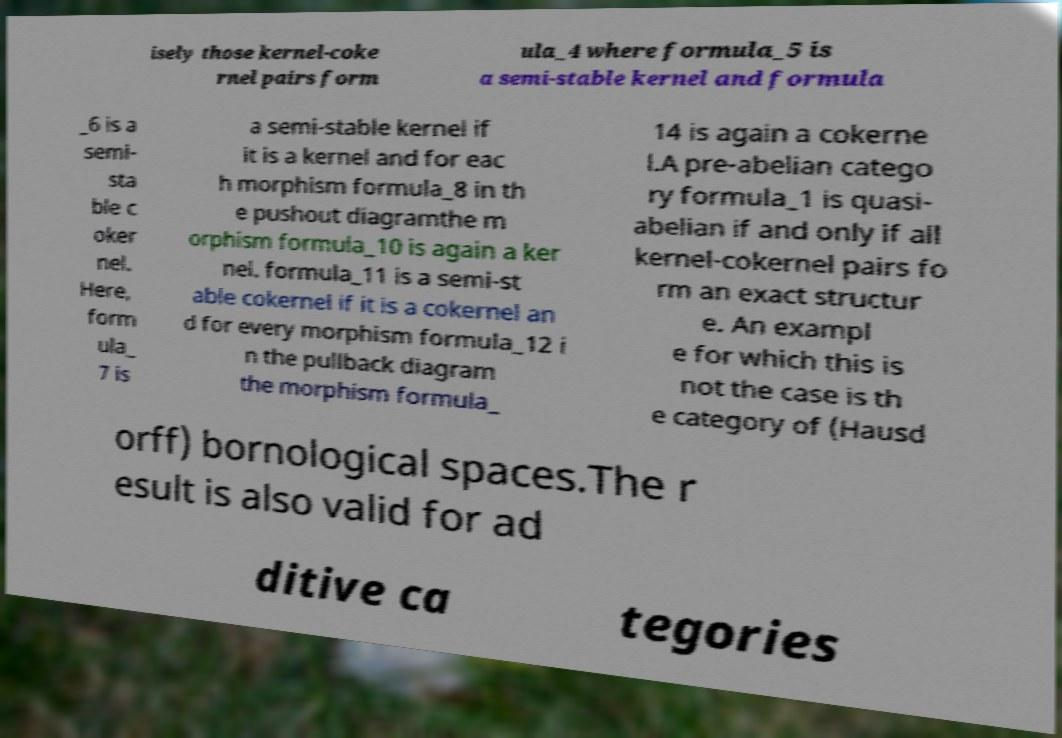Could you extract and type out the text from this image? isely those kernel-coke rnel pairs form ula_4 where formula_5 is a semi-stable kernel and formula _6 is a semi- sta ble c oker nel. Here, form ula_ 7 is a semi-stable kernel if it is a kernel and for eac h morphism formula_8 in th e pushout diagramthe m orphism formula_10 is again a ker nel. formula_11 is a semi-st able cokernel if it is a cokernel an d for every morphism formula_12 i n the pullback diagram the morphism formula_ 14 is again a cokerne l.A pre-abelian catego ry formula_1 is quasi- abelian if and only if all kernel-cokernel pairs fo rm an exact structur e. An exampl e for which this is not the case is th e category of (Hausd orff) bornological spaces.The r esult is also valid for ad ditive ca tegories 